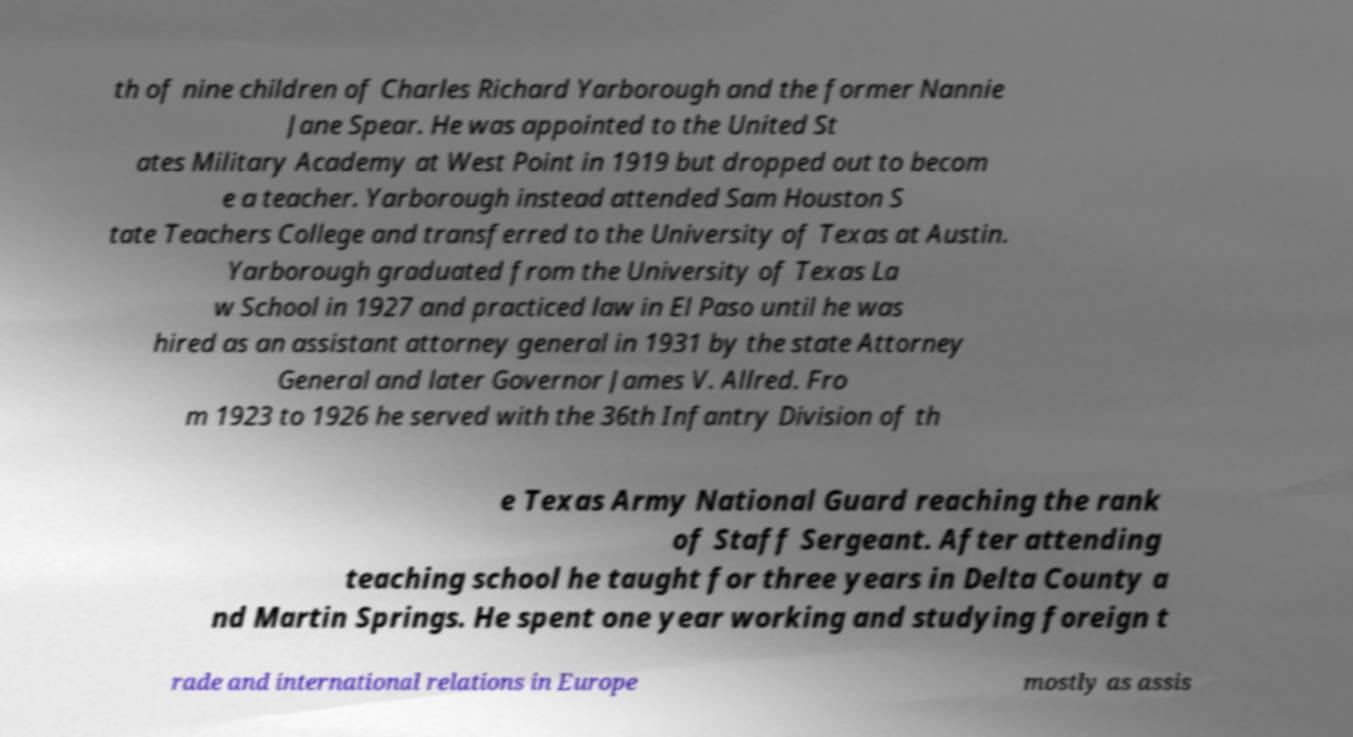For documentation purposes, I need the text within this image transcribed. Could you provide that? th of nine children of Charles Richard Yarborough and the former Nannie Jane Spear. He was appointed to the United St ates Military Academy at West Point in 1919 but dropped out to becom e a teacher. Yarborough instead attended Sam Houston S tate Teachers College and transferred to the University of Texas at Austin. Yarborough graduated from the University of Texas La w School in 1927 and practiced law in El Paso until he was hired as an assistant attorney general in 1931 by the state Attorney General and later Governor James V. Allred. Fro m 1923 to 1926 he served with the 36th Infantry Division of th e Texas Army National Guard reaching the rank of Staff Sergeant. After attending teaching school he taught for three years in Delta County a nd Martin Springs. He spent one year working and studying foreign t rade and international relations in Europe mostly as assis 